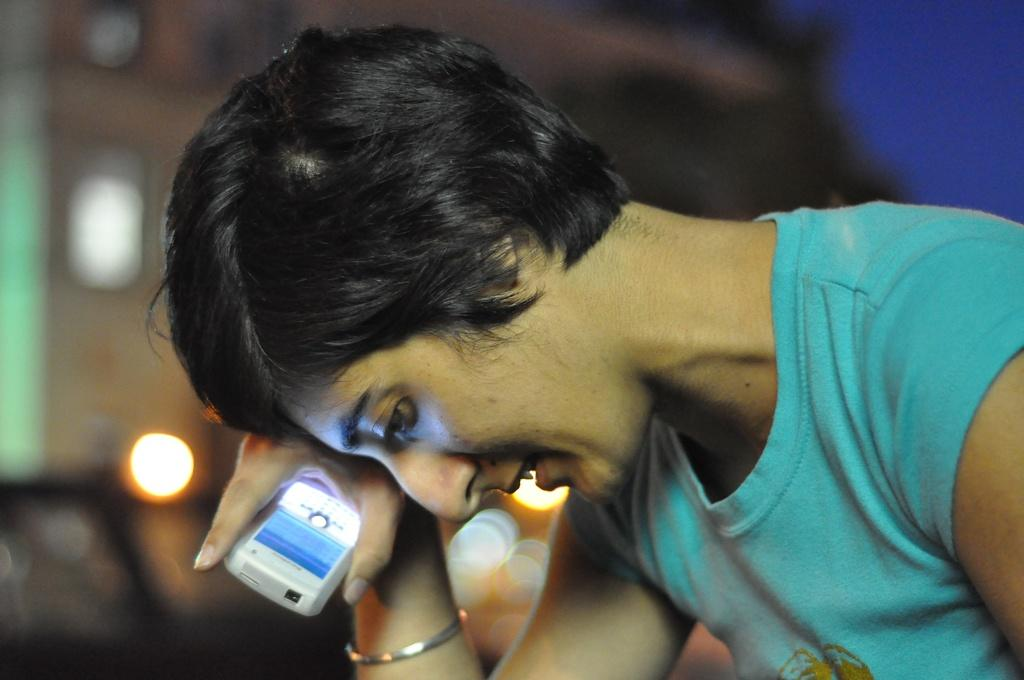What is the main subject of the image? There is a person in the image. What is the person doing in the image? The person is holding an object. Can you describe the background of the image? The background of the image is blurred. What type of feast is being prepared by the person's toes in the image? There is no mention of a feast or toes in the image; it only shows a person holding an object with a blurred background. 